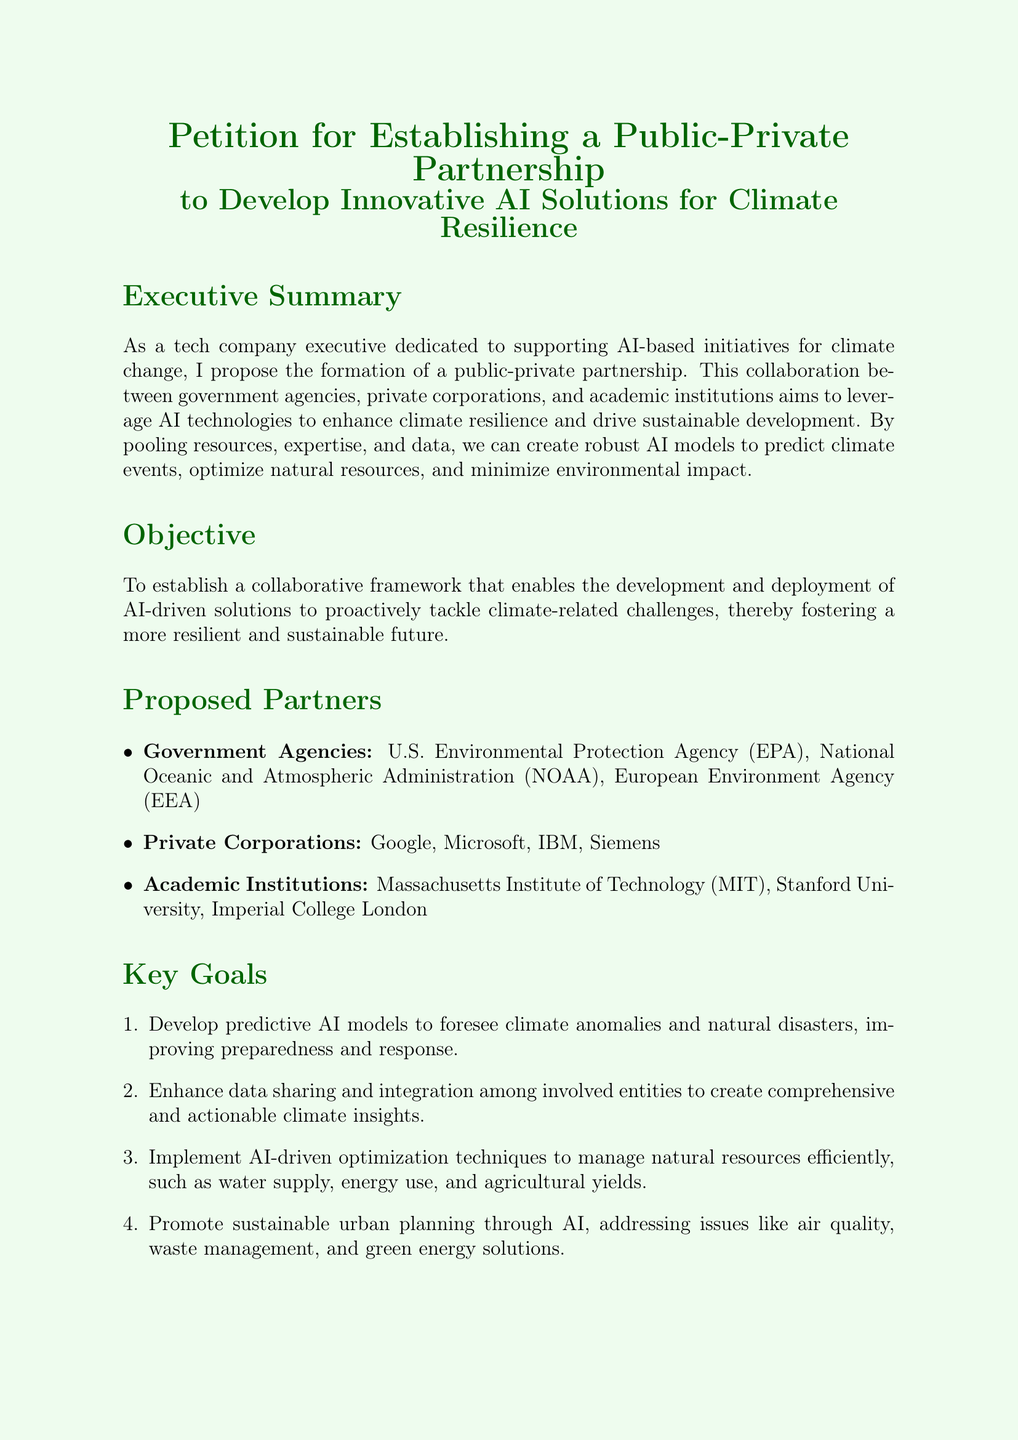What is the title of the petition? The title is prominently displayed at the top of the document, indicating the main subject of the petition.
Answer: Petition for Establishing a Public-Private Partnership to Develop Innovative AI Solutions for Climate Resilience Who are the proposed government partners mentioned? The document lists U.S. Environmental Protection Agency, National Oceanic and Atmospheric Administration, and European Environment Agency as proposed partners.
Answer: U.S. Environmental Protection Agency, National Oceanic and Atmospheric Administration, European Environment Agency What is the first key goal outlined in the document? The first key goal is mentioned in the "Key Goals" section, summarizing the main objective of AI modeling in climate resilience.
Answer: Develop predictive AI models to foresee climate anomalies and natural disasters How many private corporations are listed as proposed partners? The document explicitly enumerates the private corporations involved, informing the reader about partnerships with tech companies.
Answer: Four What is the primary objective of the petition? The objective is stated clearly in a specific section of the document, outlining the purpose of the collaboration.
Answer: To establish a collaborative framework for AI-driven solutions What does the petition urge policymakers to do? The "Call to Action" section details the commitments sought from different stakeholders.
Answer: Endorse this petition What type of partnership is being proposed? The document uses this specific term in the title and throughout the text to define the nature of the collaboration.
Answer: Public-Private Partnership How many academic institutions are proposed as partners? The document specifies the number of academic institutions listed in the "Proposed Partners" section.
Answer: Three What color theme is used in the document? The document features specific color choices throughout the layout, indicating the visual theme associated with climate initiatives.
Answer: Light green and dark green 